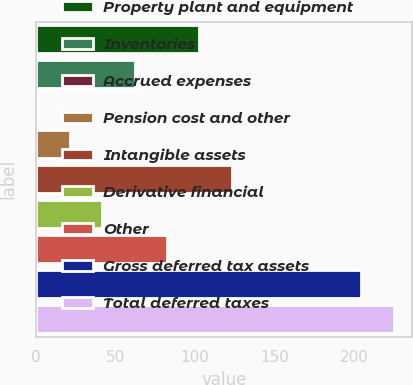<chart> <loc_0><loc_0><loc_500><loc_500><bar_chart><fcel>Property plant and equipment<fcel>Inventories<fcel>Accrued expenses<fcel>Pension cost and other<fcel>Intangible assets<fcel>Derivative financial<fcel>Other<fcel>Gross deferred tax assets<fcel>Total deferred taxes<nl><fcel>102.75<fcel>61.97<fcel>0.8<fcel>21.19<fcel>123.14<fcel>41.58<fcel>82.36<fcel>204.7<fcel>225.09<nl></chart> 